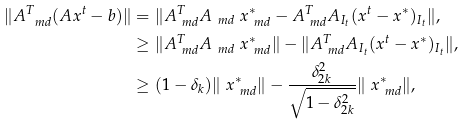<formula> <loc_0><loc_0><loc_500><loc_500>\| A ^ { T } _ { \ m d } ( A x ^ { t } - b ) \| & = \| A ^ { T } _ { \ m d } A _ { \ m d } \ x ^ { * } _ { \ m d } - A ^ { T } _ { \ m d } A _ { I _ { t } } ( x ^ { t } - x ^ { * } ) _ { I _ { t } } \| , \\ & \geq \| A ^ { T } _ { \ m d } A _ { \ m d } \ x ^ { * } _ { \ m d } \| - \| A ^ { T } _ { \ m d } A _ { I _ { t } } ( x ^ { t } - x ^ { * } ) _ { I _ { t } } \| , \\ & \geq ( 1 - \delta _ { k } ) \| \ x ^ { * } _ { \ m d } \| - \frac { \delta _ { 2 k } ^ { 2 } } { \sqrt { 1 - \delta _ { 2 k } ^ { 2 } } } \| \ x ^ { * } _ { \ m d } \| ,</formula> 